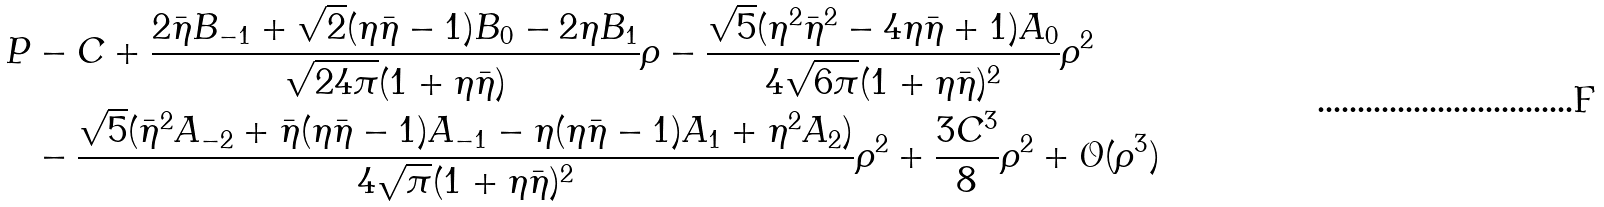Convert formula to latex. <formula><loc_0><loc_0><loc_500><loc_500>P & - C + \frac { 2 \bar { \eta } B _ { - 1 } + \sqrt { 2 } ( \eta \bar { \eta } - 1 ) B _ { 0 } - 2 \eta B _ { 1 } } { \sqrt { 2 4 \pi } ( 1 + \eta \bar { \eta } ) } \rho - \frac { \sqrt { 5 } ( \eta ^ { 2 } \bar { \eta } ^ { 2 } - 4 \eta \bar { \eta } + 1 ) A _ { 0 } } { 4 \sqrt { 6 \pi } ( 1 + \eta \bar { \eta } ) ^ { 2 } } \rho ^ { 2 } \\ & - \frac { \sqrt { 5 } ( \bar { \eta } ^ { 2 } A _ { - 2 } + \bar { \eta } ( \eta \bar { \eta } - 1 ) A _ { - 1 } - \eta ( \eta \bar { \eta } - 1 ) A _ { 1 } + \eta ^ { 2 } A _ { 2 } ) } { 4 \sqrt { \pi } ( 1 + \eta \bar { \eta } ) ^ { 2 } } \rho ^ { 2 } + \frac { 3 C ^ { 3 } } { 8 } \rho ^ { 2 } + { \mathcal { O } } ( \rho ^ { 3 } )</formula> 